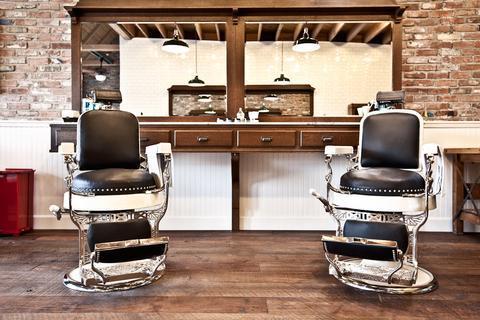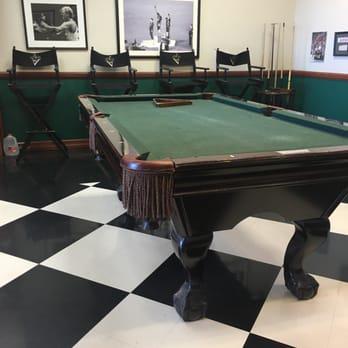The first image is the image on the left, the second image is the image on the right. Assess this claim about the two images: "In at least one image there are two empty leather barber chairs.". Correct or not? Answer yes or no. Yes. The first image is the image on the left, the second image is the image on the right. Given the left and right images, does the statement "A barber is standing behind a client who is sitting." hold true? Answer yes or no. No. 